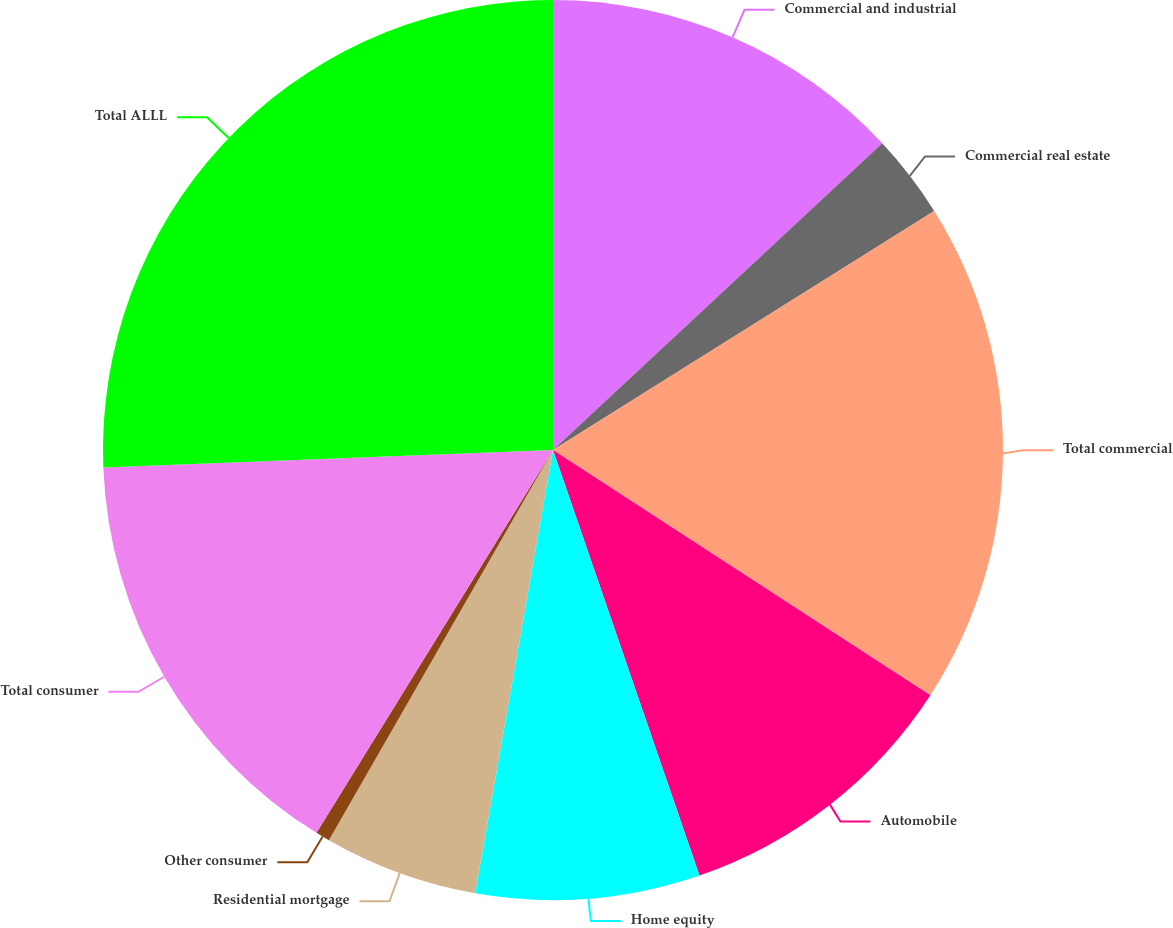Convert chart to OTSL. <chart><loc_0><loc_0><loc_500><loc_500><pie_chart><fcel>Commercial and industrial<fcel>Commercial real estate<fcel>Total commercial<fcel>Automobile<fcel>Home equity<fcel>Residential mortgage<fcel>Other consumer<fcel>Total consumer<fcel>Total ALLL<nl><fcel>13.06%<fcel>3.02%<fcel>18.08%<fcel>10.55%<fcel>8.04%<fcel>5.53%<fcel>0.51%<fcel>15.57%<fcel>25.61%<nl></chart> 